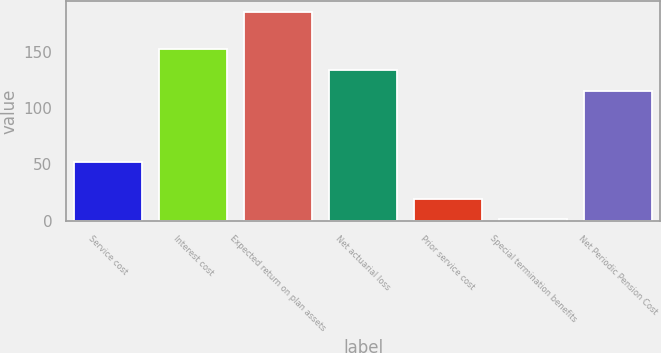Convert chart. <chart><loc_0><loc_0><loc_500><loc_500><bar_chart><fcel>Service cost<fcel>Interest cost<fcel>Expected return on plan assets<fcel>Net actuarial loss<fcel>Prior service cost<fcel>Special termination benefits<fcel>Net Periodic Pension Cost<nl><fcel>51.8<fcel>151.94<fcel>185.4<fcel>133.52<fcel>19.62<fcel>1.2<fcel>115.1<nl></chart> 